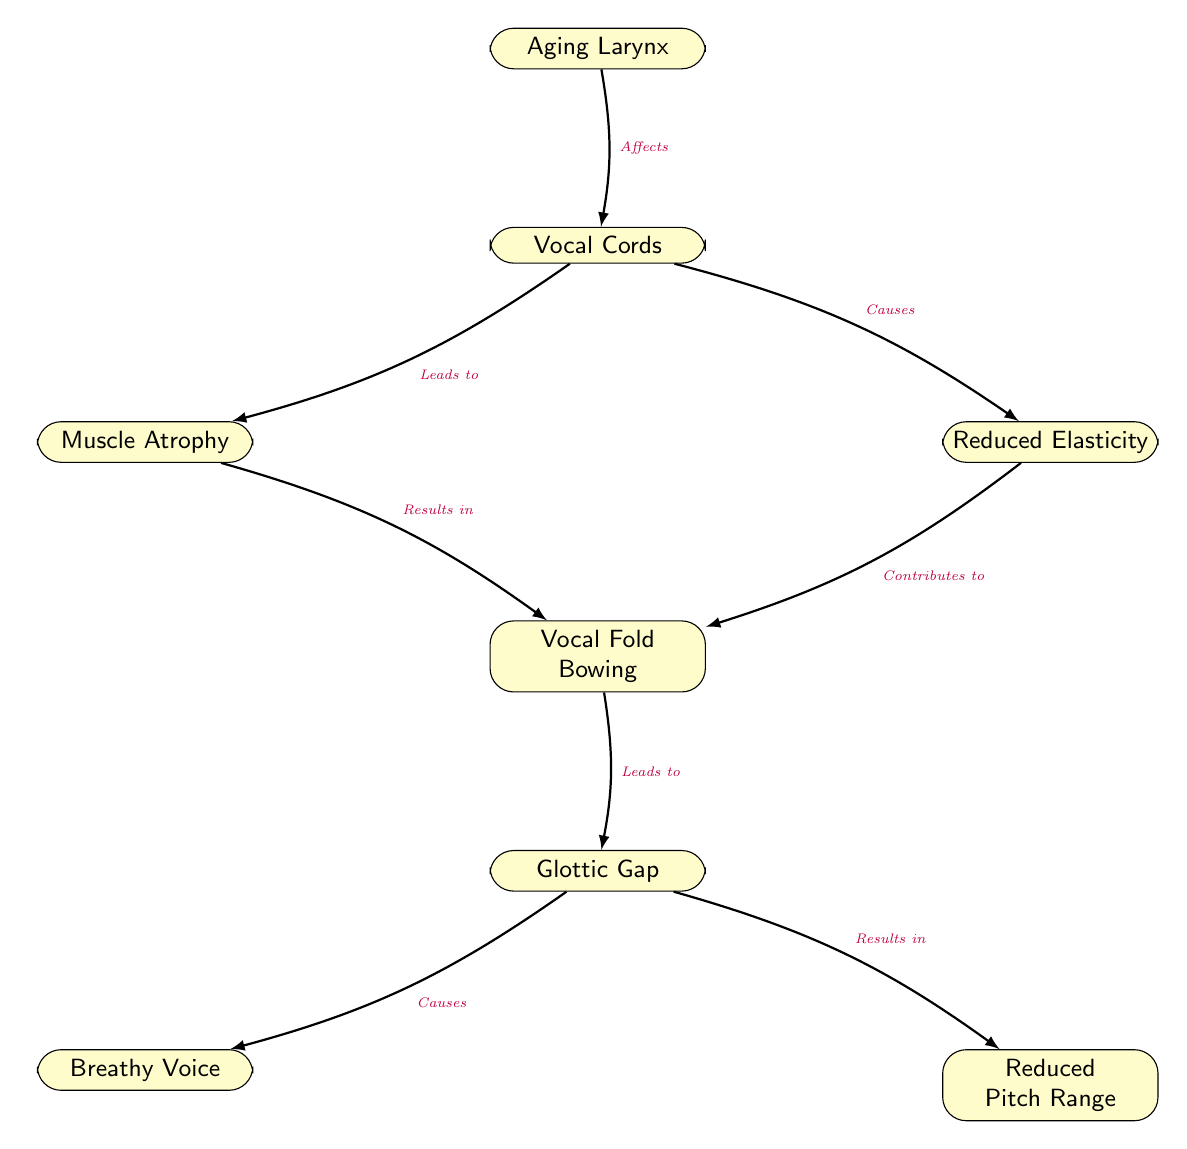What is the primary focus of the diagram? The diagram illustrates the relationship between the aging larynx and its impact on vocal quality, specifically detailing various changes that occur during the aging process.
Answer: Aging Larynx How many nodes are present in the diagram? Counting all the nodes displayed in the diagram, there are a total of 8 nodes including the main focus and the effects on vocal quality.
Answer: 8 What does "Muscle Atrophy" lead to? Tracing the connections in the diagram, "Muscle Atrophy" has a directed edge that leads to "Vocal Fold Bowing," indicating this is the resulting effect.
Answer: Vocal Fold Bowing What relationship exists between "Reduced Elasticity" and "Vocal Fold Bowing"? The diagram shows a directional edge from "Reduced Elasticity" to "Vocal Fold Bowing," indicating that a decrease in elasticity contributes to the condition of vocal fold bowing.
Answer: Contributes to What are the two effects that arise from a "Glottic Gap"? The diagram illustrates that both "Breathy Voice" and "Reduced Pitch Range" are outcomes that result from the "Glottic Gap." This indicates that a gap in the glottis affects vocal production in two specific ways.
Answer: Breathy Voice and Reduced Pitch Range Which node is the last step impacting vocal quality? Following the direction of the edges from the starting point of the “Aging Larynx,” the final node before vocal quality is affected is “Glottic Gap,” indicating that this is the last physical change before vocal quality is impacted.
Answer: Glottic Gap How does "Aging Larynx" affect the vocal cords? The directional edge from "Aging Larynx" to "Vocal Cords" indicates that aging directly affects the vocal cords, confirming the main influence of aging on vocal functionality.
Answer: Affects What connects "Muscle Atrophy" to "Vocal Fold Bowing"? "Muscle Atrophy" directly leads to "Vocal Fold Bowing" as shown by the directed edge, indicating a cause-effect relationship in the context of laryngeal aging.
Answer: Leads to What two factors lead to "Vocal Fold Bowing"? The diagram shows that both "Muscle Atrophy" and "Reduced Elasticity" contribute to "Vocal Fold Bowing," indicating that multiple factors can result in this condition.
Answer: Muscle Atrophy and Reduced Elasticity 